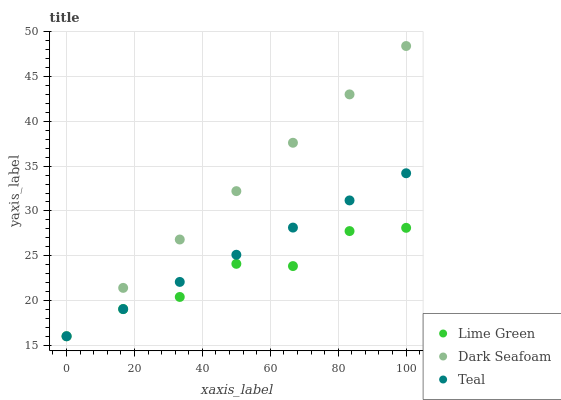Does Lime Green have the minimum area under the curve?
Answer yes or no. Yes. Does Dark Seafoam have the maximum area under the curve?
Answer yes or no. Yes. Does Teal have the minimum area under the curve?
Answer yes or no. No. Does Teal have the maximum area under the curve?
Answer yes or no. No. Is Teal the smoothest?
Answer yes or no. Yes. Is Lime Green the roughest?
Answer yes or no. Yes. Is Lime Green the smoothest?
Answer yes or no. No. Is Teal the roughest?
Answer yes or no. No. Does Dark Seafoam have the lowest value?
Answer yes or no. Yes. Does Dark Seafoam have the highest value?
Answer yes or no. Yes. Does Teal have the highest value?
Answer yes or no. No. Does Lime Green intersect Dark Seafoam?
Answer yes or no. Yes. Is Lime Green less than Dark Seafoam?
Answer yes or no. No. Is Lime Green greater than Dark Seafoam?
Answer yes or no. No. 